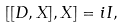<formula> <loc_0><loc_0><loc_500><loc_500>[ [ D , X ] , X ] = i I ,</formula> 